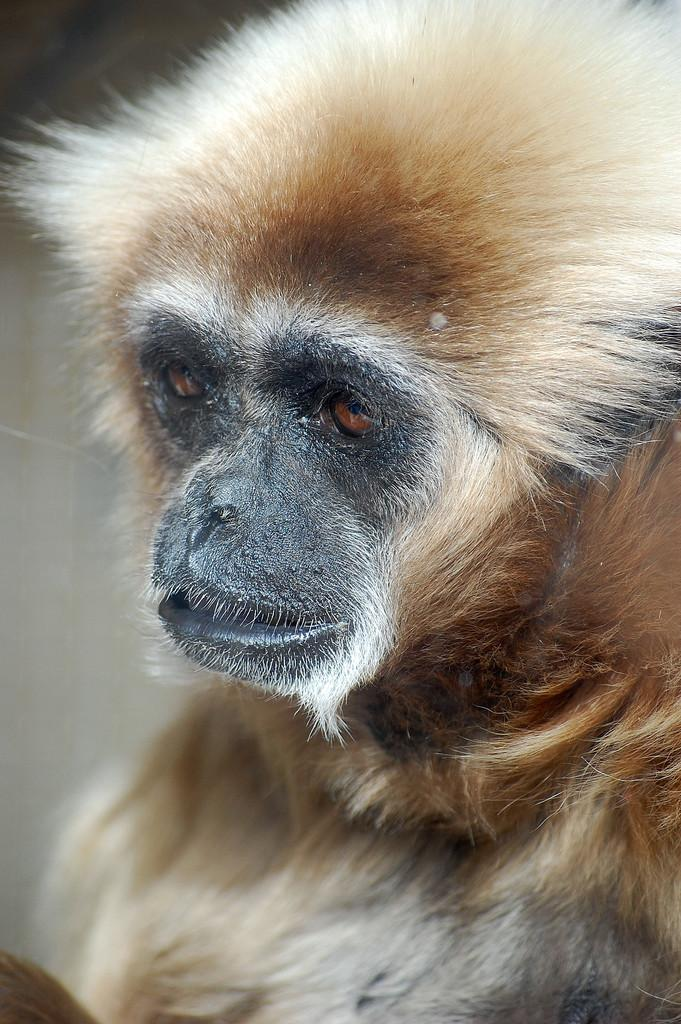What type of animal is present in the image? There is a monkey in the image. How much money does the actor receive for ploughing the field in the image? There is no actor or field in the image, and therefore no ploughing or money exchange can be observed. 